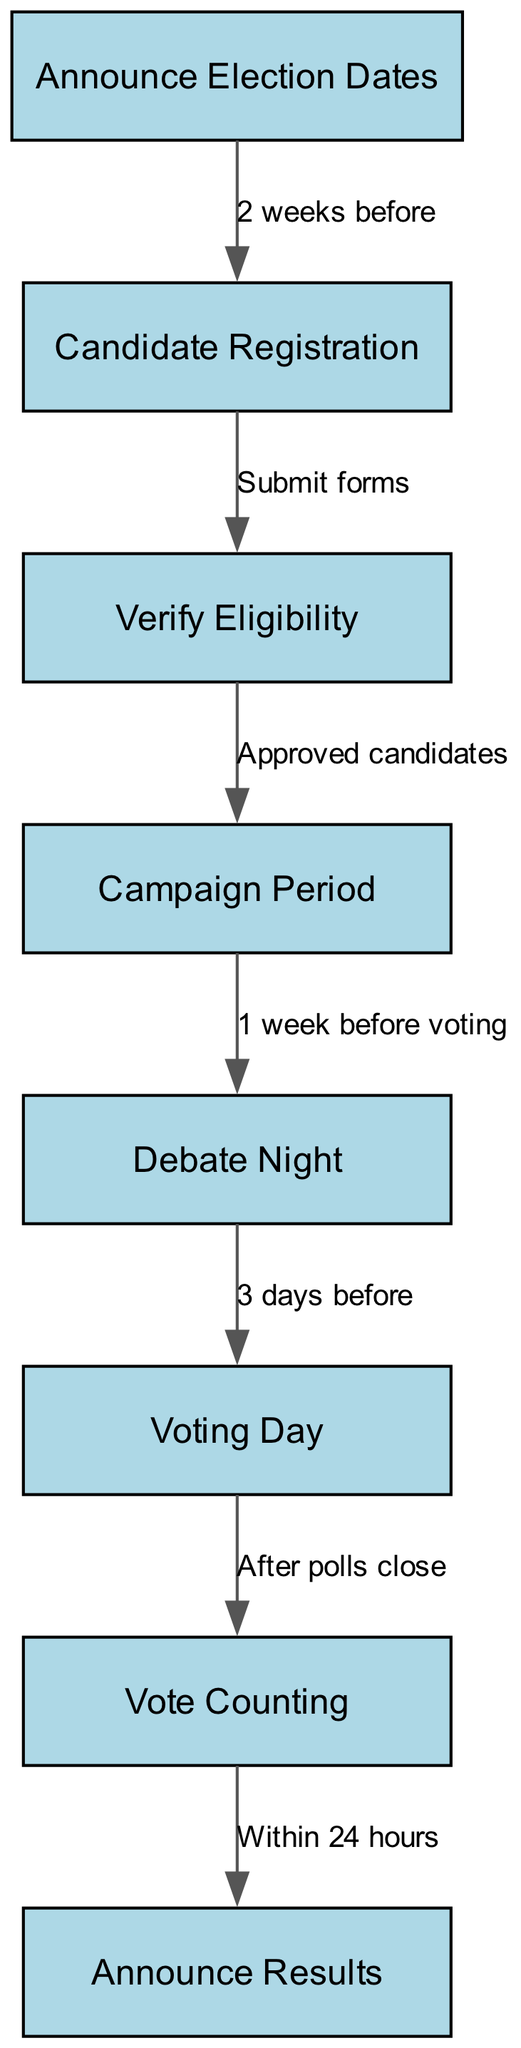What is the first step in the election process? According to the diagram, the first step in the election process is "Announce Election Dates". This is indicated as the starting node in the flowchart.
Answer: Announce Election Dates How many nodes are there in the diagram? By counting the items listed under "nodes" in the data, there are a total of 8 nodes represented in the diagram.
Answer: 8 What is the relationship between "Debate Night" and "Voting Day"? The edge from "Debate Night" to "Voting Day" shows a transition labeled "3 days before", indicating this is the timeframe when Debate Night occurs relative to Voting Day.
Answer: 3 days before What action is required after "Candidate Registration"? After "Candidate Registration", the next action is "Verify Eligibility", which is indicated by the directed edge in the flowchart following registration.
Answer: Verify Eligibility Which stage follows "Vote Counting"? The stage that follows "Vote Counting" is "Announce Results", as indicated by the edge leading from "Vote Counting" to "Announce Results".
Answer: Announce Results What step occurs 1 week before voting? The step that occurs 1 week before voting is "Debate Night", shown in the diagram as the action just before "Voting Day".
Answer: Debate Night What happens if a candidate is not approved? If a candidate is not approved during the "Verify Eligibility" step, they would not continue to the "Campaign Period", as only approved candidates progress. This reasoning comes from the flowchart's clear direction from "Verify Eligibility" to "Campaign Period".
Answer: Not approved How is the timeline structured for the entire election process? The timeline starts with “Announce Election Dates”, followed by a steady progression through candidate registration, eligibility checks, campaigning, debating, voting, counting votes, and finally announcing results. Each step is systematically lined up to illustrate a clear process.
Answer: Timeline structured sequentially 